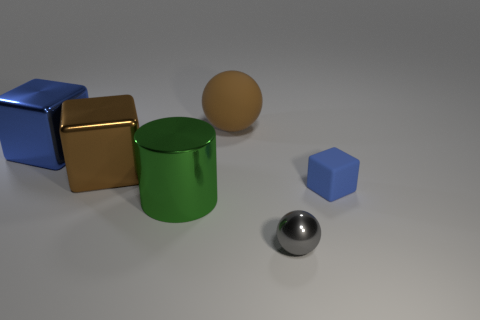Add 2 tiny purple balls. How many objects exist? 8 Subtract all cylinders. How many objects are left? 5 Subtract 0 purple blocks. How many objects are left? 6 Subtract all big blocks. Subtract all small yellow objects. How many objects are left? 4 Add 2 balls. How many balls are left? 4 Add 6 big spheres. How many big spheres exist? 7 